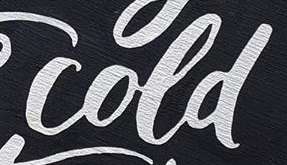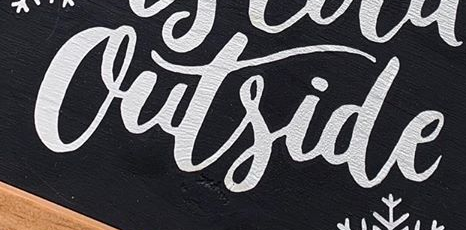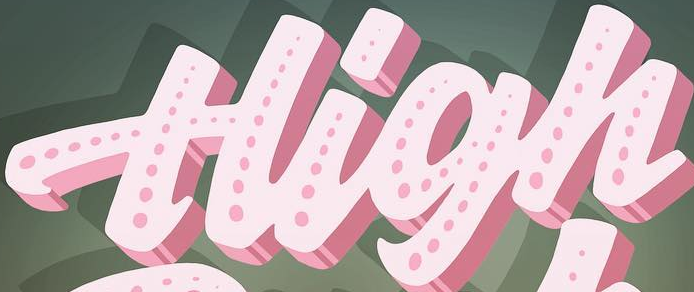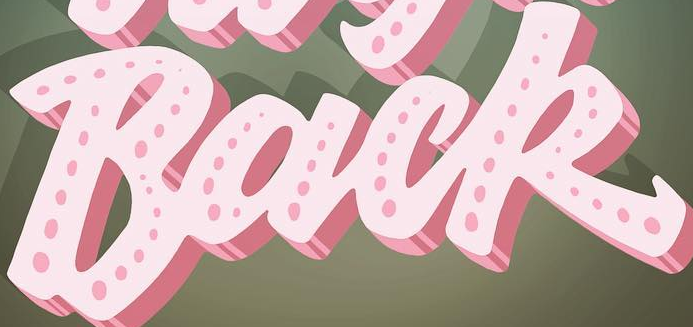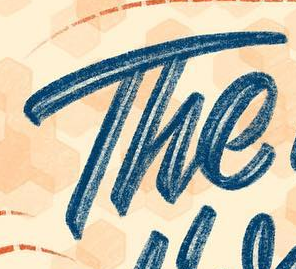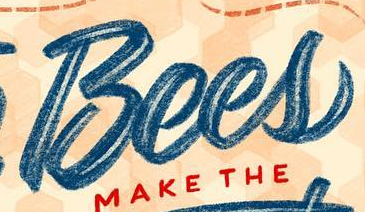What text appears in these images from left to right, separated by a semicolon? cold; Outside; High; Back; The; Bees 